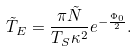<formula> <loc_0><loc_0><loc_500><loc_500>\tilde { T } _ { E } = \frac { \pi \tilde { N } } { T _ { S } \kappa ^ { 2 } } e ^ { - \frac { \Phi _ { 0 } } { 2 } } .</formula> 